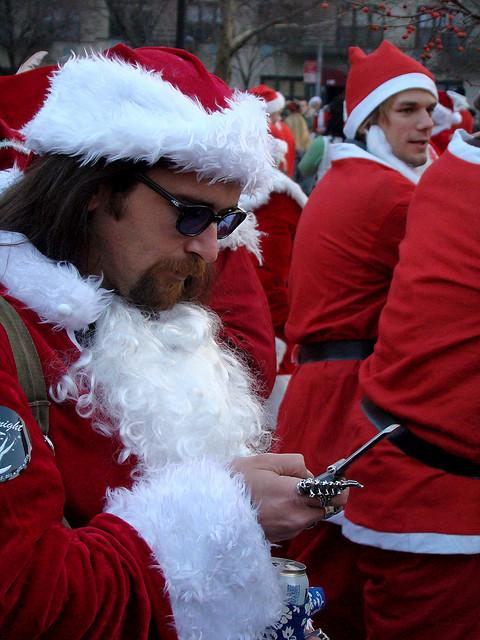What Christmas character are these people all dressed up as?

Choices:
A) grinch
B) santa clause
C) elves
D) reindeer santa clause 